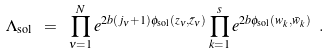Convert formula to latex. <formula><loc_0><loc_0><loc_500><loc_500>\Lambda _ { \text {sol} } \ = \ \prod _ { \nu = 1 } ^ { N } e ^ { 2 b ( j _ { \nu } + 1 ) \phi _ { \text {sol} } ( z _ { \nu } , \bar { z } _ { \nu } ) } \prod _ { k = 1 } ^ { s } e ^ { 2 b \phi _ { \text {sol} } ( w _ { k } , \bar { w } _ { k } ) } \ .</formula> 